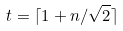Convert formula to latex. <formula><loc_0><loc_0><loc_500><loc_500>t = \lceil 1 + n / \sqrt { 2 } \rceil</formula> 